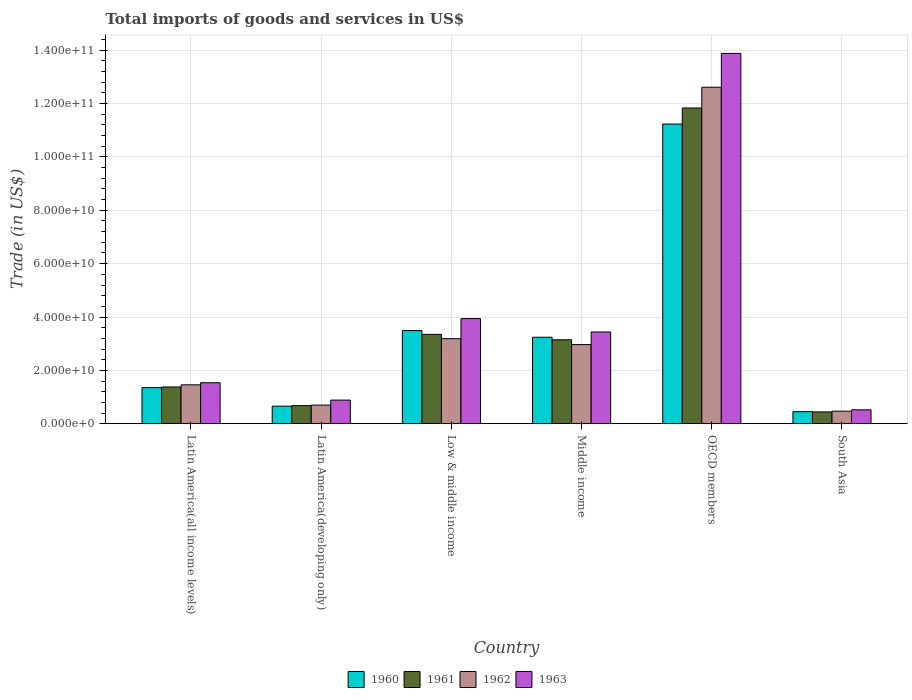Are the number of bars on each tick of the X-axis equal?
Your response must be concise. Yes. How many bars are there on the 6th tick from the left?
Ensure brevity in your answer.  4. How many bars are there on the 4th tick from the right?
Your answer should be very brief. 4. What is the label of the 4th group of bars from the left?
Offer a terse response. Middle income. What is the total imports of goods and services in 1960 in Middle income?
Your response must be concise. 3.24e+1. Across all countries, what is the maximum total imports of goods and services in 1960?
Offer a terse response. 1.12e+11. Across all countries, what is the minimum total imports of goods and services in 1961?
Offer a very short reply. 4.43e+09. In which country was the total imports of goods and services in 1961 maximum?
Your answer should be very brief. OECD members. What is the total total imports of goods and services in 1961 in the graph?
Make the answer very short. 2.08e+11. What is the difference between the total imports of goods and services in 1961 in Latin America(all income levels) and that in Latin America(developing only)?
Ensure brevity in your answer.  7.00e+09. What is the difference between the total imports of goods and services in 1961 in South Asia and the total imports of goods and services in 1962 in Middle income?
Make the answer very short. -2.52e+1. What is the average total imports of goods and services in 1963 per country?
Your answer should be compact. 4.03e+1. What is the difference between the total imports of goods and services of/in 1963 and total imports of goods and services of/in 1961 in Latin America(all income levels)?
Provide a succinct answer. 1.59e+09. In how many countries, is the total imports of goods and services in 1962 greater than 124000000000 US$?
Provide a short and direct response. 1. What is the ratio of the total imports of goods and services in 1963 in Latin America(all income levels) to that in OECD members?
Your answer should be compact. 0.11. Is the total imports of goods and services in 1963 in Latin America(all income levels) less than that in Middle income?
Provide a short and direct response. Yes. What is the difference between the highest and the second highest total imports of goods and services in 1963?
Offer a very short reply. 5.01e+09. What is the difference between the highest and the lowest total imports of goods and services in 1961?
Offer a terse response. 1.14e+11. In how many countries, is the total imports of goods and services in 1962 greater than the average total imports of goods and services in 1962 taken over all countries?
Ensure brevity in your answer.  1. What does the 4th bar from the left in Low & middle income represents?
Provide a short and direct response. 1963. Is it the case that in every country, the sum of the total imports of goods and services in 1961 and total imports of goods and services in 1960 is greater than the total imports of goods and services in 1962?
Provide a short and direct response. Yes. How many bars are there?
Make the answer very short. 24. How many countries are there in the graph?
Your answer should be compact. 6. What is the difference between two consecutive major ticks on the Y-axis?
Your response must be concise. 2.00e+1. Are the values on the major ticks of Y-axis written in scientific E-notation?
Give a very brief answer. Yes. Does the graph contain any zero values?
Your answer should be compact. No. Where does the legend appear in the graph?
Make the answer very short. Bottom center. How are the legend labels stacked?
Your answer should be very brief. Horizontal. What is the title of the graph?
Provide a short and direct response. Total imports of goods and services in US$. What is the label or title of the X-axis?
Provide a succinct answer. Country. What is the label or title of the Y-axis?
Provide a short and direct response. Trade (in US$). What is the Trade (in US$) of 1960 in Latin America(all income levels)?
Give a very brief answer. 1.35e+1. What is the Trade (in US$) of 1961 in Latin America(all income levels)?
Your answer should be very brief. 1.38e+1. What is the Trade (in US$) of 1962 in Latin America(all income levels)?
Provide a short and direct response. 1.46e+1. What is the Trade (in US$) of 1963 in Latin America(all income levels)?
Keep it short and to the point. 1.54e+1. What is the Trade (in US$) of 1960 in Latin America(developing only)?
Make the answer very short. 6.59e+09. What is the Trade (in US$) in 1961 in Latin America(developing only)?
Your response must be concise. 6.78e+09. What is the Trade (in US$) in 1962 in Latin America(developing only)?
Make the answer very short. 6.99e+09. What is the Trade (in US$) in 1963 in Latin America(developing only)?
Make the answer very short. 8.86e+09. What is the Trade (in US$) in 1960 in Low & middle income?
Ensure brevity in your answer.  3.49e+1. What is the Trade (in US$) of 1961 in Low & middle income?
Your response must be concise. 3.35e+1. What is the Trade (in US$) of 1962 in Low & middle income?
Offer a very short reply. 3.19e+1. What is the Trade (in US$) in 1963 in Low & middle income?
Your response must be concise. 3.94e+1. What is the Trade (in US$) in 1960 in Middle income?
Provide a succinct answer. 3.24e+1. What is the Trade (in US$) of 1961 in Middle income?
Make the answer very short. 3.15e+1. What is the Trade (in US$) of 1962 in Middle income?
Your response must be concise. 2.97e+1. What is the Trade (in US$) of 1963 in Middle income?
Give a very brief answer. 3.44e+1. What is the Trade (in US$) in 1960 in OECD members?
Ensure brevity in your answer.  1.12e+11. What is the Trade (in US$) of 1961 in OECD members?
Your answer should be very brief. 1.18e+11. What is the Trade (in US$) of 1962 in OECD members?
Your answer should be compact. 1.26e+11. What is the Trade (in US$) of 1963 in OECD members?
Your answer should be compact. 1.39e+11. What is the Trade (in US$) in 1960 in South Asia?
Offer a terse response. 4.53e+09. What is the Trade (in US$) of 1961 in South Asia?
Make the answer very short. 4.43e+09. What is the Trade (in US$) in 1962 in South Asia?
Make the answer very short. 4.71e+09. What is the Trade (in US$) of 1963 in South Asia?
Ensure brevity in your answer.  5.21e+09. Across all countries, what is the maximum Trade (in US$) of 1960?
Offer a very short reply. 1.12e+11. Across all countries, what is the maximum Trade (in US$) in 1961?
Offer a terse response. 1.18e+11. Across all countries, what is the maximum Trade (in US$) in 1962?
Your answer should be compact. 1.26e+11. Across all countries, what is the maximum Trade (in US$) in 1963?
Offer a terse response. 1.39e+11. Across all countries, what is the minimum Trade (in US$) in 1960?
Ensure brevity in your answer.  4.53e+09. Across all countries, what is the minimum Trade (in US$) in 1961?
Your response must be concise. 4.43e+09. Across all countries, what is the minimum Trade (in US$) of 1962?
Your response must be concise. 4.71e+09. Across all countries, what is the minimum Trade (in US$) in 1963?
Offer a terse response. 5.21e+09. What is the total Trade (in US$) in 1960 in the graph?
Provide a short and direct response. 2.04e+11. What is the total Trade (in US$) in 1961 in the graph?
Provide a succinct answer. 2.08e+11. What is the total Trade (in US$) of 1962 in the graph?
Your answer should be compact. 2.14e+11. What is the total Trade (in US$) of 1963 in the graph?
Provide a short and direct response. 2.42e+11. What is the difference between the Trade (in US$) of 1960 in Latin America(all income levels) and that in Latin America(developing only)?
Provide a succinct answer. 6.94e+09. What is the difference between the Trade (in US$) in 1961 in Latin America(all income levels) and that in Latin America(developing only)?
Keep it short and to the point. 7.00e+09. What is the difference between the Trade (in US$) in 1962 in Latin America(all income levels) and that in Latin America(developing only)?
Your response must be concise. 7.59e+09. What is the difference between the Trade (in US$) of 1963 in Latin America(all income levels) and that in Latin America(developing only)?
Provide a succinct answer. 6.50e+09. What is the difference between the Trade (in US$) of 1960 in Latin America(all income levels) and that in Low & middle income?
Offer a very short reply. -2.14e+1. What is the difference between the Trade (in US$) in 1961 in Latin America(all income levels) and that in Low & middle income?
Offer a terse response. -1.97e+1. What is the difference between the Trade (in US$) of 1962 in Latin America(all income levels) and that in Low & middle income?
Offer a very short reply. -1.73e+1. What is the difference between the Trade (in US$) in 1963 in Latin America(all income levels) and that in Low & middle income?
Ensure brevity in your answer.  -2.40e+1. What is the difference between the Trade (in US$) in 1960 in Latin America(all income levels) and that in Middle income?
Offer a very short reply. -1.89e+1. What is the difference between the Trade (in US$) in 1961 in Latin America(all income levels) and that in Middle income?
Make the answer very short. -1.77e+1. What is the difference between the Trade (in US$) of 1962 in Latin America(all income levels) and that in Middle income?
Keep it short and to the point. -1.51e+1. What is the difference between the Trade (in US$) in 1963 in Latin America(all income levels) and that in Middle income?
Provide a short and direct response. -1.90e+1. What is the difference between the Trade (in US$) in 1960 in Latin America(all income levels) and that in OECD members?
Your answer should be compact. -9.88e+1. What is the difference between the Trade (in US$) in 1961 in Latin America(all income levels) and that in OECD members?
Provide a succinct answer. -1.05e+11. What is the difference between the Trade (in US$) of 1962 in Latin America(all income levels) and that in OECD members?
Offer a very short reply. -1.12e+11. What is the difference between the Trade (in US$) in 1963 in Latin America(all income levels) and that in OECD members?
Your response must be concise. -1.23e+11. What is the difference between the Trade (in US$) in 1960 in Latin America(all income levels) and that in South Asia?
Make the answer very short. 9.00e+09. What is the difference between the Trade (in US$) in 1961 in Latin America(all income levels) and that in South Asia?
Ensure brevity in your answer.  9.35e+09. What is the difference between the Trade (in US$) of 1962 in Latin America(all income levels) and that in South Asia?
Offer a very short reply. 9.87e+09. What is the difference between the Trade (in US$) in 1963 in Latin America(all income levels) and that in South Asia?
Keep it short and to the point. 1.02e+1. What is the difference between the Trade (in US$) in 1960 in Latin America(developing only) and that in Low & middle income?
Give a very brief answer. -2.83e+1. What is the difference between the Trade (in US$) of 1961 in Latin America(developing only) and that in Low & middle income?
Give a very brief answer. -2.67e+1. What is the difference between the Trade (in US$) of 1962 in Latin America(developing only) and that in Low & middle income?
Your answer should be very brief. -2.49e+1. What is the difference between the Trade (in US$) in 1963 in Latin America(developing only) and that in Low & middle income?
Your answer should be compact. -3.05e+1. What is the difference between the Trade (in US$) of 1960 in Latin America(developing only) and that in Middle income?
Provide a short and direct response. -2.58e+1. What is the difference between the Trade (in US$) of 1961 in Latin America(developing only) and that in Middle income?
Offer a terse response. -2.47e+1. What is the difference between the Trade (in US$) in 1962 in Latin America(developing only) and that in Middle income?
Your answer should be compact. -2.27e+1. What is the difference between the Trade (in US$) of 1963 in Latin America(developing only) and that in Middle income?
Provide a short and direct response. -2.55e+1. What is the difference between the Trade (in US$) in 1960 in Latin America(developing only) and that in OECD members?
Your response must be concise. -1.06e+11. What is the difference between the Trade (in US$) of 1961 in Latin America(developing only) and that in OECD members?
Give a very brief answer. -1.12e+11. What is the difference between the Trade (in US$) in 1962 in Latin America(developing only) and that in OECD members?
Your response must be concise. -1.19e+11. What is the difference between the Trade (in US$) of 1963 in Latin America(developing only) and that in OECD members?
Offer a very short reply. -1.30e+11. What is the difference between the Trade (in US$) of 1960 in Latin America(developing only) and that in South Asia?
Offer a very short reply. 2.06e+09. What is the difference between the Trade (in US$) of 1961 in Latin America(developing only) and that in South Asia?
Offer a terse response. 2.35e+09. What is the difference between the Trade (in US$) in 1962 in Latin America(developing only) and that in South Asia?
Give a very brief answer. 2.27e+09. What is the difference between the Trade (in US$) in 1963 in Latin America(developing only) and that in South Asia?
Ensure brevity in your answer.  3.65e+09. What is the difference between the Trade (in US$) in 1960 in Low & middle income and that in Middle income?
Keep it short and to the point. 2.50e+09. What is the difference between the Trade (in US$) in 1961 in Low & middle income and that in Middle income?
Make the answer very short. 2.04e+09. What is the difference between the Trade (in US$) in 1962 in Low & middle income and that in Middle income?
Make the answer very short. 2.21e+09. What is the difference between the Trade (in US$) in 1963 in Low & middle income and that in Middle income?
Make the answer very short. 5.01e+09. What is the difference between the Trade (in US$) in 1960 in Low & middle income and that in OECD members?
Provide a short and direct response. -7.74e+1. What is the difference between the Trade (in US$) of 1961 in Low & middle income and that in OECD members?
Provide a succinct answer. -8.48e+1. What is the difference between the Trade (in US$) of 1962 in Low & middle income and that in OECD members?
Make the answer very short. -9.43e+1. What is the difference between the Trade (in US$) of 1963 in Low & middle income and that in OECD members?
Offer a terse response. -9.94e+1. What is the difference between the Trade (in US$) of 1960 in Low & middle income and that in South Asia?
Provide a short and direct response. 3.04e+1. What is the difference between the Trade (in US$) of 1961 in Low & middle income and that in South Asia?
Provide a short and direct response. 2.91e+1. What is the difference between the Trade (in US$) in 1962 in Low & middle income and that in South Asia?
Give a very brief answer. 2.72e+1. What is the difference between the Trade (in US$) of 1963 in Low & middle income and that in South Asia?
Your response must be concise. 3.42e+1. What is the difference between the Trade (in US$) in 1960 in Middle income and that in OECD members?
Make the answer very short. -7.99e+1. What is the difference between the Trade (in US$) of 1961 in Middle income and that in OECD members?
Provide a short and direct response. -8.69e+1. What is the difference between the Trade (in US$) of 1962 in Middle income and that in OECD members?
Your answer should be compact. -9.65e+1. What is the difference between the Trade (in US$) in 1963 in Middle income and that in OECD members?
Make the answer very short. -1.04e+11. What is the difference between the Trade (in US$) in 1960 in Middle income and that in South Asia?
Your answer should be compact. 2.79e+1. What is the difference between the Trade (in US$) in 1961 in Middle income and that in South Asia?
Make the answer very short. 2.70e+1. What is the difference between the Trade (in US$) of 1962 in Middle income and that in South Asia?
Your response must be concise. 2.50e+1. What is the difference between the Trade (in US$) in 1963 in Middle income and that in South Asia?
Your answer should be compact. 2.92e+1. What is the difference between the Trade (in US$) in 1960 in OECD members and that in South Asia?
Ensure brevity in your answer.  1.08e+11. What is the difference between the Trade (in US$) of 1961 in OECD members and that in South Asia?
Give a very brief answer. 1.14e+11. What is the difference between the Trade (in US$) in 1962 in OECD members and that in South Asia?
Your answer should be compact. 1.21e+11. What is the difference between the Trade (in US$) in 1963 in OECD members and that in South Asia?
Offer a terse response. 1.34e+11. What is the difference between the Trade (in US$) in 1960 in Latin America(all income levels) and the Trade (in US$) in 1961 in Latin America(developing only)?
Offer a very short reply. 6.75e+09. What is the difference between the Trade (in US$) of 1960 in Latin America(all income levels) and the Trade (in US$) of 1962 in Latin America(developing only)?
Ensure brevity in your answer.  6.55e+09. What is the difference between the Trade (in US$) of 1960 in Latin America(all income levels) and the Trade (in US$) of 1963 in Latin America(developing only)?
Provide a succinct answer. 4.67e+09. What is the difference between the Trade (in US$) of 1961 in Latin America(all income levels) and the Trade (in US$) of 1962 in Latin America(developing only)?
Provide a succinct answer. 6.79e+09. What is the difference between the Trade (in US$) of 1961 in Latin America(all income levels) and the Trade (in US$) of 1963 in Latin America(developing only)?
Offer a terse response. 4.92e+09. What is the difference between the Trade (in US$) of 1962 in Latin America(all income levels) and the Trade (in US$) of 1963 in Latin America(developing only)?
Ensure brevity in your answer.  5.72e+09. What is the difference between the Trade (in US$) in 1960 in Latin America(all income levels) and the Trade (in US$) in 1961 in Low & middle income?
Ensure brevity in your answer.  -2.00e+1. What is the difference between the Trade (in US$) of 1960 in Latin America(all income levels) and the Trade (in US$) of 1962 in Low & middle income?
Make the answer very short. -1.83e+1. What is the difference between the Trade (in US$) in 1960 in Latin America(all income levels) and the Trade (in US$) in 1963 in Low & middle income?
Give a very brief answer. -2.59e+1. What is the difference between the Trade (in US$) of 1961 in Latin America(all income levels) and the Trade (in US$) of 1962 in Low & middle income?
Make the answer very short. -1.81e+1. What is the difference between the Trade (in US$) of 1961 in Latin America(all income levels) and the Trade (in US$) of 1963 in Low & middle income?
Give a very brief answer. -2.56e+1. What is the difference between the Trade (in US$) of 1962 in Latin America(all income levels) and the Trade (in US$) of 1963 in Low & middle income?
Provide a short and direct response. -2.48e+1. What is the difference between the Trade (in US$) of 1960 in Latin America(all income levels) and the Trade (in US$) of 1961 in Middle income?
Your response must be concise. -1.79e+1. What is the difference between the Trade (in US$) in 1960 in Latin America(all income levels) and the Trade (in US$) in 1962 in Middle income?
Keep it short and to the point. -1.61e+1. What is the difference between the Trade (in US$) of 1960 in Latin America(all income levels) and the Trade (in US$) of 1963 in Middle income?
Your answer should be compact. -2.09e+1. What is the difference between the Trade (in US$) of 1961 in Latin America(all income levels) and the Trade (in US$) of 1962 in Middle income?
Offer a very short reply. -1.59e+1. What is the difference between the Trade (in US$) of 1961 in Latin America(all income levels) and the Trade (in US$) of 1963 in Middle income?
Offer a terse response. -2.06e+1. What is the difference between the Trade (in US$) of 1962 in Latin America(all income levels) and the Trade (in US$) of 1963 in Middle income?
Make the answer very short. -1.98e+1. What is the difference between the Trade (in US$) in 1960 in Latin America(all income levels) and the Trade (in US$) in 1961 in OECD members?
Provide a succinct answer. -1.05e+11. What is the difference between the Trade (in US$) in 1960 in Latin America(all income levels) and the Trade (in US$) in 1962 in OECD members?
Give a very brief answer. -1.13e+11. What is the difference between the Trade (in US$) of 1960 in Latin America(all income levels) and the Trade (in US$) of 1963 in OECD members?
Keep it short and to the point. -1.25e+11. What is the difference between the Trade (in US$) in 1961 in Latin America(all income levels) and the Trade (in US$) in 1962 in OECD members?
Your response must be concise. -1.12e+11. What is the difference between the Trade (in US$) in 1961 in Latin America(all income levels) and the Trade (in US$) in 1963 in OECD members?
Give a very brief answer. -1.25e+11. What is the difference between the Trade (in US$) of 1962 in Latin America(all income levels) and the Trade (in US$) of 1963 in OECD members?
Ensure brevity in your answer.  -1.24e+11. What is the difference between the Trade (in US$) in 1960 in Latin America(all income levels) and the Trade (in US$) in 1961 in South Asia?
Make the answer very short. 9.10e+09. What is the difference between the Trade (in US$) of 1960 in Latin America(all income levels) and the Trade (in US$) of 1962 in South Asia?
Give a very brief answer. 8.82e+09. What is the difference between the Trade (in US$) in 1960 in Latin America(all income levels) and the Trade (in US$) in 1963 in South Asia?
Your response must be concise. 8.32e+09. What is the difference between the Trade (in US$) in 1961 in Latin America(all income levels) and the Trade (in US$) in 1962 in South Asia?
Keep it short and to the point. 9.07e+09. What is the difference between the Trade (in US$) of 1961 in Latin America(all income levels) and the Trade (in US$) of 1963 in South Asia?
Ensure brevity in your answer.  8.57e+09. What is the difference between the Trade (in US$) of 1962 in Latin America(all income levels) and the Trade (in US$) of 1963 in South Asia?
Offer a terse response. 9.37e+09. What is the difference between the Trade (in US$) in 1960 in Latin America(developing only) and the Trade (in US$) in 1961 in Low & middle income?
Your answer should be very brief. -2.69e+1. What is the difference between the Trade (in US$) in 1960 in Latin America(developing only) and the Trade (in US$) in 1962 in Low & middle income?
Your answer should be very brief. -2.53e+1. What is the difference between the Trade (in US$) in 1960 in Latin America(developing only) and the Trade (in US$) in 1963 in Low & middle income?
Provide a short and direct response. -3.28e+1. What is the difference between the Trade (in US$) in 1961 in Latin America(developing only) and the Trade (in US$) in 1962 in Low & middle income?
Your response must be concise. -2.51e+1. What is the difference between the Trade (in US$) of 1961 in Latin America(developing only) and the Trade (in US$) of 1963 in Low & middle income?
Offer a very short reply. -3.26e+1. What is the difference between the Trade (in US$) of 1962 in Latin America(developing only) and the Trade (in US$) of 1963 in Low & middle income?
Your answer should be very brief. -3.24e+1. What is the difference between the Trade (in US$) of 1960 in Latin America(developing only) and the Trade (in US$) of 1961 in Middle income?
Provide a short and direct response. -2.49e+1. What is the difference between the Trade (in US$) in 1960 in Latin America(developing only) and the Trade (in US$) in 1962 in Middle income?
Give a very brief answer. -2.31e+1. What is the difference between the Trade (in US$) of 1960 in Latin America(developing only) and the Trade (in US$) of 1963 in Middle income?
Your response must be concise. -2.78e+1. What is the difference between the Trade (in US$) of 1961 in Latin America(developing only) and the Trade (in US$) of 1962 in Middle income?
Your response must be concise. -2.29e+1. What is the difference between the Trade (in US$) of 1961 in Latin America(developing only) and the Trade (in US$) of 1963 in Middle income?
Your response must be concise. -2.76e+1. What is the difference between the Trade (in US$) of 1962 in Latin America(developing only) and the Trade (in US$) of 1963 in Middle income?
Provide a short and direct response. -2.74e+1. What is the difference between the Trade (in US$) of 1960 in Latin America(developing only) and the Trade (in US$) of 1961 in OECD members?
Offer a terse response. -1.12e+11. What is the difference between the Trade (in US$) of 1960 in Latin America(developing only) and the Trade (in US$) of 1962 in OECD members?
Offer a very short reply. -1.20e+11. What is the difference between the Trade (in US$) of 1960 in Latin America(developing only) and the Trade (in US$) of 1963 in OECD members?
Provide a succinct answer. -1.32e+11. What is the difference between the Trade (in US$) in 1961 in Latin America(developing only) and the Trade (in US$) in 1962 in OECD members?
Your response must be concise. -1.19e+11. What is the difference between the Trade (in US$) of 1961 in Latin America(developing only) and the Trade (in US$) of 1963 in OECD members?
Provide a short and direct response. -1.32e+11. What is the difference between the Trade (in US$) of 1962 in Latin America(developing only) and the Trade (in US$) of 1963 in OECD members?
Your answer should be very brief. -1.32e+11. What is the difference between the Trade (in US$) of 1960 in Latin America(developing only) and the Trade (in US$) of 1961 in South Asia?
Your response must be concise. 2.16e+09. What is the difference between the Trade (in US$) of 1960 in Latin America(developing only) and the Trade (in US$) of 1962 in South Asia?
Offer a terse response. 1.88e+09. What is the difference between the Trade (in US$) in 1960 in Latin America(developing only) and the Trade (in US$) in 1963 in South Asia?
Offer a very short reply. 1.38e+09. What is the difference between the Trade (in US$) in 1961 in Latin America(developing only) and the Trade (in US$) in 1962 in South Asia?
Provide a succinct answer. 2.07e+09. What is the difference between the Trade (in US$) in 1961 in Latin America(developing only) and the Trade (in US$) in 1963 in South Asia?
Your answer should be compact. 1.57e+09. What is the difference between the Trade (in US$) in 1962 in Latin America(developing only) and the Trade (in US$) in 1963 in South Asia?
Provide a short and direct response. 1.77e+09. What is the difference between the Trade (in US$) of 1960 in Low & middle income and the Trade (in US$) of 1961 in Middle income?
Give a very brief answer. 3.46e+09. What is the difference between the Trade (in US$) of 1960 in Low & middle income and the Trade (in US$) of 1962 in Middle income?
Your response must be concise. 5.26e+09. What is the difference between the Trade (in US$) of 1960 in Low & middle income and the Trade (in US$) of 1963 in Middle income?
Give a very brief answer. 5.30e+08. What is the difference between the Trade (in US$) in 1961 in Low & middle income and the Trade (in US$) in 1962 in Middle income?
Offer a very short reply. 3.84e+09. What is the difference between the Trade (in US$) of 1961 in Low & middle income and the Trade (in US$) of 1963 in Middle income?
Offer a terse response. -8.90e+08. What is the difference between the Trade (in US$) in 1962 in Low & middle income and the Trade (in US$) in 1963 in Middle income?
Your answer should be very brief. -2.51e+09. What is the difference between the Trade (in US$) in 1960 in Low & middle income and the Trade (in US$) in 1961 in OECD members?
Provide a succinct answer. -8.34e+1. What is the difference between the Trade (in US$) of 1960 in Low & middle income and the Trade (in US$) of 1962 in OECD members?
Your answer should be compact. -9.12e+1. What is the difference between the Trade (in US$) of 1960 in Low & middle income and the Trade (in US$) of 1963 in OECD members?
Your answer should be very brief. -1.04e+11. What is the difference between the Trade (in US$) in 1961 in Low & middle income and the Trade (in US$) in 1962 in OECD members?
Offer a terse response. -9.26e+1. What is the difference between the Trade (in US$) in 1961 in Low & middle income and the Trade (in US$) in 1963 in OECD members?
Your response must be concise. -1.05e+11. What is the difference between the Trade (in US$) in 1962 in Low & middle income and the Trade (in US$) in 1963 in OECD members?
Your answer should be compact. -1.07e+11. What is the difference between the Trade (in US$) in 1960 in Low & middle income and the Trade (in US$) in 1961 in South Asia?
Provide a succinct answer. 3.05e+1. What is the difference between the Trade (in US$) of 1960 in Low & middle income and the Trade (in US$) of 1962 in South Asia?
Give a very brief answer. 3.02e+1. What is the difference between the Trade (in US$) in 1960 in Low & middle income and the Trade (in US$) in 1963 in South Asia?
Make the answer very short. 2.97e+1. What is the difference between the Trade (in US$) in 1961 in Low & middle income and the Trade (in US$) in 1962 in South Asia?
Provide a succinct answer. 2.88e+1. What is the difference between the Trade (in US$) in 1961 in Low & middle income and the Trade (in US$) in 1963 in South Asia?
Give a very brief answer. 2.83e+1. What is the difference between the Trade (in US$) in 1962 in Low & middle income and the Trade (in US$) in 1963 in South Asia?
Your response must be concise. 2.67e+1. What is the difference between the Trade (in US$) in 1960 in Middle income and the Trade (in US$) in 1961 in OECD members?
Ensure brevity in your answer.  -8.59e+1. What is the difference between the Trade (in US$) in 1960 in Middle income and the Trade (in US$) in 1962 in OECD members?
Give a very brief answer. -9.37e+1. What is the difference between the Trade (in US$) of 1960 in Middle income and the Trade (in US$) of 1963 in OECD members?
Your answer should be very brief. -1.06e+11. What is the difference between the Trade (in US$) in 1961 in Middle income and the Trade (in US$) in 1962 in OECD members?
Offer a terse response. -9.47e+1. What is the difference between the Trade (in US$) in 1961 in Middle income and the Trade (in US$) in 1963 in OECD members?
Keep it short and to the point. -1.07e+11. What is the difference between the Trade (in US$) in 1962 in Middle income and the Trade (in US$) in 1963 in OECD members?
Keep it short and to the point. -1.09e+11. What is the difference between the Trade (in US$) in 1960 in Middle income and the Trade (in US$) in 1961 in South Asia?
Keep it short and to the point. 2.80e+1. What is the difference between the Trade (in US$) in 1960 in Middle income and the Trade (in US$) in 1962 in South Asia?
Ensure brevity in your answer.  2.77e+1. What is the difference between the Trade (in US$) of 1960 in Middle income and the Trade (in US$) of 1963 in South Asia?
Your response must be concise. 2.72e+1. What is the difference between the Trade (in US$) of 1961 in Middle income and the Trade (in US$) of 1962 in South Asia?
Offer a terse response. 2.68e+1. What is the difference between the Trade (in US$) in 1961 in Middle income and the Trade (in US$) in 1963 in South Asia?
Ensure brevity in your answer.  2.63e+1. What is the difference between the Trade (in US$) of 1962 in Middle income and the Trade (in US$) of 1963 in South Asia?
Your answer should be very brief. 2.45e+1. What is the difference between the Trade (in US$) in 1960 in OECD members and the Trade (in US$) in 1961 in South Asia?
Give a very brief answer. 1.08e+11. What is the difference between the Trade (in US$) in 1960 in OECD members and the Trade (in US$) in 1962 in South Asia?
Keep it short and to the point. 1.08e+11. What is the difference between the Trade (in US$) of 1960 in OECD members and the Trade (in US$) of 1963 in South Asia?
Your response must be concise. 1.07e+11. What is the difference between the Trade (in US$) in 1961 in OECD members and the Trade (in US$) in 1962 in South Asia?
Offer a terse response. 1.14e+11. What is the difference between the Trade (in US$) of 1961 in OECD members and the Trade (in US$) of 1963 in South Asia?
Offer a terse response. 1.13e+11. What is the difference between the Trade (in US$) of 1962 in OECD members and the Trade (in US$) of 1963 in South Asia?
Provide a succinct answer. 1.21e+11. What is the average Trade (in US$) of 1960 per country?
Keep it short and to the point. 3.41e+1. What is the average Trade (in US$) of 1961 per country?
Offer a very short reply. 3.47e+1. What is the average Trade (in US$) of 1962 per country?
Give a very brief answer. 3.57e+1. What is the average Trade (in US$) in 1963 per country?
Offer a very short reply. 4.03e+1. What is the difference between the Trade (in US$) of 1960 and Trade (in US$) of 1961 in Latin America(all income levels)?
Offer a very short reply. -2.48e+08. What is the difference between the Trade (in US$) in 1960 and Trade (in US$) in 1962 in Latin America(all income levels)?
Ensure brevity in your answer.  -1.05e+09. What is the difference between the Trade (in US$) in 1960 and Trade (in US$) in 1963 in Latin America(all income levels)?
Offer a very short reply. -1.83e+09. What is the difference between the Trade (in US$) in 1961 and Trade (in US$) in 1962 in Latin America(all income levels)?
Your response must be concise. -7.99e+08. What is the difference between the Trade (in US$) of 1961 and Trade (in US$) of 1963 in Latin America(all income levels)?
Keep it short and to the point. -1.59e+09. What is the difference between the Trade (in US$) in 1962 and Trade (in US$) in 1963 in Latin America(all income levels)?
Offer a terse response. -7.87e+08. What is the difference between the Trade (in US$) in 1960 and Trade (in US$) in 1961 in Latin America(developing only)?
Offer a very short reply. -1.91e+08. What is the difference between the Trade (in US$) in 1960 and Trade (in US$) in 1962 in Latin America(developing only)?
Provide a short and direct response. -3.96e+08. What is the difference between the Trade (in US$) in 1960 and Trade (in US$) in 1963 in Latin America(developing only)?
Ensure brevity in your answer.  -2.27e+09. What is the difference between the Trade (in US$) in 1961 and Trade (in US$) in 1962 in Latin America(developing only)?
Your response must be concise. -2.05e+08. What is the difference between the Trade (in US$) in 1961 and Trade (in US$) in 1963 in Latin America(developing only)?
Make the answer very short. -2.08e+09. What is the difference between the Trade (in US$) of 1962 and Trade (in US$) of 1963 in Latin America(developing only)?
Provide a short and direct response. -1.88e+09. What is the difference between the Trade (in US$) in 1960 and Trade (in US$) in 1961 in Low & middle income?
Offer a very short reply. 1.42e+09. What is the difference between the Trade (in US$) in 1960 and Trade (in US$) in 1962 in Low & middle income?
Give a very brief answer. 3.05e+09. What is the difference between the Trade (in US$) of 1960 and Trade (in US$) of 1963 in Low & middle income?
Provide a succinct answer. -4.48e+09. What is the difference between the Trade (in US$) in 1961 and Trade (in US$) in 1962 in Low & middle income?
Give a very brief answer. 1.62e+09. What is the difference between the Trade (in US$) in 1961 and Trade (in US$) in 1963 in Low & middle income?
Your response must be concise. -5.90e+09. What is the difference between the Trade (in US$) in 1962 and Trade (in US$) in 1963 in Low & middle income?
Your response must be concise. -7.52e+09. What is the difference between the Trade (in US$) in 1960 and Trade (in US$) in 1961 in Middle income?
Your response must be concise. 9.57e+08. What is the difference between the Trade (in US$) in 1960 and Trade (in US$) in 1962 in Middle income?
Make the answer very short. 2.76e+09. What is the difference between the Trade (in US$) of 1960 and Trade (in US$) of 1963 in Middle income?
Keep it short and to the point. -1.97e+09. What is the difference between the Trade (in US$) in 1961 and Trade (in US$) in 1962 in Middle income?
Keep it short and to the point. 1.80e+09. What is the difference between the Trade (in US$) of 1961 and Trade (in US$) of 1963 in Middle income?
Your answer should be very brief. -2.93e+09. What is the difference between the Trade (in US$) of 1962 and Trade (in US$) of 1963 in Middle income?
Offer a terse response. -4.73e+09. What is the difference between the Trade (in US$) of 1960 and Trade (in US$) of 1961 in OECD members?
Keep it short and to the point. -6.01e+09. What is the difference between the Trade (in US$) in 1960 and Trade (in US$) in 1962 in OECD members?
Your response must be concise. -1.38e+1. What is the difference between the Trade (in US$) of 1960 and Trade (in US$) of 1963 in OECD members?
Keep it short and to the point. -2.65e+1. What is the difference between the Trade (in US$) in 1961 and Trade (in US$) in 1962 in OECD members?
Keep it short and to the point. -7.79e+09. What is the difference between the Trade (in US$) in 1961 and Trade (in US$) in 1963 in OECD members?
Ensure brevity in your answer.  -2.05e+1. What is the difference between the Trade (in US$) of 1962 and Trade (in US$) of 1963 in OECD members?
Offer a very short reply. -1.27e+1. What is the difference between the Trade (in US$) in 1960 and Trade (in US$) in 1961 in South Asia?
Your answer should be compact. 9.31e+07. What is the difference between the Trade (in US$) of 1960 and Trade (in US$) of 1962 in South Asia?
Keep it short and to the point. -1.84e+08. What is the difference between the Trade (in US$) in 1960 and Trade (in US$) in 1963 in South Asia?
Ensure brevity in your answer.  -6.84e+08. What is the difference between the Trade (in US$) of 1961 and Trade (in US$) of 1962 in South Asia?
Provide a succinct answer. -2.77e+08. What is the difference between the Trade (in US$) in 1961 and Trade (in US$) in 1963 in South Asia?
Your response must be concise. -7.77e+08. What is the difference between the Trade (in US$) in 1962 and Trade (in US$) in 1963 in South Asia?
Give a very brief answer. -5.00e+08. What is the ratio of the Trade (in US$) of 1960 in Latin America(all income levels) to that in Latin America(developing only)?
Make the answer very short. 2.05. What is the ratio of the Trade (in US$) of 1961 in Latin America(all income levels) to that in Latin America(developing only)?
Offer a very short reply. 2.03. What is the ratio of the Trade (in US$) in 1962 in Latin America(all income levels) to that in Latin America(developing only)?
Offer a terse response. 2.09. What is the ratio of the Trade (in US$) of 1963 in Latin America(all income levels) to that in Latin America(developing only)?
Your answer should be very brief. 1.73. What is the ratio of the Trade (in US$) of 1960 in Latin America(all income levels) to that in Low & middle income?
Provide a short and direct response. 0.39. What is the ratio of the Trade (in US$) of 1961 in Latin America(all income levels) to that in Low & middle income?
Your answer should be compact. 0.41. What is the ratio of the Trade (in US$) in 1962 in Latin America(all income levels) to that in Low & middle income?
Keep it short and to the point. 0.46. What is the ratio of the Trade (in US$) in 1963 in Latin America(all income levels) to that in Low & middle income?
Offer a very short reply. 0.39. What is the ratio of the Trade (in US$) in 1960 in Latin America(all income levels) to that in Middle income?
Your response must be concise. 0.42. What is the ratio of the Trade (in US$) in 1961 in Latin America(all income levels) to that in Middle income?
Provide a succinct answer. 0.44. What is the ratio of the Trade (in US$) in 1962 in Latin America(all income levels) to that in Middle income?
Ensure brevity in your answer.  0.49. What is the ratio of the Trade (in US$) of 1963 in Latin America(all income levels) to that in Middle income?
Your answer should be very brief. 0.45. What is the ratio of the Trade (in US$) of 1960 in Latin America(all income levels) to that in OECD members?
Your answer should be very brief. 0.12. What is the ratio of the Trade (in US$) of 1961 in Latin America(all income levels) to that in OECD members?
Your answer should be very brief. 0.12. What is the ratio of the Trade (in US$) of 1962 in Latin America(all income levels) to that in OECD members?
Your response must be concise. 0.12. What is the ratio of the Trade (in US$) of 1963 in Latin America(all income levels) to that in OECD members?
Offer a very short reply. 0.11. What is the ratio of the Trade (in US$) of 1960 in Latin America(all income levels) to that in South Asia?
Provide a short and direct response. 2.99. What is the ratio of the Trade (in US$) in 1961 in Latin America(all income levels) to that in South Asia?
Your response must be concise. 3.11. What is the ratio of the Trade (in US$) in 1962 in Latin America(all income levels) to that in South Asia?
Make the answer very short. 3.09. What is the ratio of the Trade (in US$) of 1963 in Latin America(all income levels) to that in South Asia?
Your response must be concise. 2.95. What is the ratio of the Trade (in US$) in 1960 in Latin America(developing only) to that in Low & middle income?
Provide a short and direct response. 0.19. What is the ratio of the Trade (in US$) of 1961 in Latin America(developing only) to that in Low & middle income?
Offer a very short reply. 0.2. What is the ratio of the Trade (in US$) in 1962 in Latin America(developing only) to that in Low & middle income?
Offer a very short reply. 0.22. What is the ratio of the Trade (in US$) of 1963 in Latin America(developing only) to that in Low & middle income?
Offer a very short reply. 0.22. What is the ratio of the Trade (in US$) in 1960 in Latin America(developing only) to that in Middle income?
Ensure brevity in your answer.  0.2. What is the ratio of the Trade (in US$) of 1961 in Latin America(developing only) to that in Middle income?
Make the answer very short. 0.22. What is the ratio of the Trade (in US$) of 1962 in Latin America(developing only) to that in Middle income?
Keep it short and to the point. 0.24. What is the ratio of the Trade (in US$) of 1963 in Latin America(developing only) to that in Middle income?
Your answer should be very brief. 0.26. What is the ratio of the Trade (in US$) in 1960 in Latin America(developing only) to that in OECD members?
Give a very brief answer. 0.06. What is the ratio of the Trade (in US$) in 1961 in Latin America(developing only) to that in OECD members?
Offer a terse response. 0.06. What is the ratio of the Trade (in US$) in 1962 in Latin America(developing only) to that in OECD members?
Provide a short and direct response. 0.06. What is the ratio of the Trade (in US$) of 1963 in Latin America(developing only) to that in OECD members?
Your response must be concise. 0.06. What is the ratio of the Trade (in US$) in 1960 in Latin America(developing only) to that in South Asia?
Give a very brief answer. 1.46. What is the ratio of the Trade (in US$) of 1961 in Latin America(developing only) to that in South Asia?
Ensure brevity in your answer.  1.53. What is the ratio of the Trade (in US$) in 1962 in Latin America(developing only) to that in South Asia?
Make the answer very short. 1.48. What is the ratio of the Trade (in US$) in 1963 in Latin America(developing only) to that in South Asia?
Provide a short and direct response. 1.7. What is the ratio of the Trade (in US$) in 1960 in Low & middle income to that in Middle income?
Ensure brevity in your answer.  1.08. What is the ratio of the Trade (in US$) of 1961 in Low & middle income to that in Middle income?
Ensure brevity in your answer.  1.06. What is the ratio of the Trade (in US$) of 1962 in Low & middle income to that in Middle income?
Offer a terse response. 1.07. What is the ratio of the Trade (in US$) of 1963 in Low & middle income to that in Middle income?
Your response must be concise. 1.15. What is the ratio of the Trade (in US$) in 1960 in Low & middle income to that in OECD members?
Ensure brevity in your answer.  0.31. What is the ratio of the Trade (in US$) in 1961 in Low & middle income to that in OECD members?
Provide a succinct answer. 0.28. What is the ratio of the Trade (in US$) in 1962 in Low & middle income to that in OECD members?
Make the answer very short. 0.25. What is the ratio of the Trade (in US$) in 1963 in Low & middle income to that in OECD members?
Make the answer very short. 0.28. What is the ratio of the Trade (in US$) in 1960 in Low & middle income to that in South Asia?
Keep it short and to the point. 7.71. What is the ratio of the Trade (in US$) of 1961 in Low & middle income to that in South Asia?
Provide a succinct answer. 7.55. What is the ratio of the Trade (in US$) in 1962 in Low & middle income to that in South Asia?
Offer a very short reply. 6.77. What is the ratio of the Trade (in US$) in 1963 in Low & middle income to that in South Asia?
Make the answer very short. 7.56. What is the ratio of the Trade (in US$) in 1960 in Middle income to that in OECD members?
Offer a very short reply. 0.29. What is the ratio of the Trade (in US$) of 1961 in Middle income to that in OECD members?
Make the answer very short. 0.27. What is the ratio of the Trade (in US$) in 1962 in Middle income to that in OECD members?
Your response must be concise. 0.24. What is the ratio of the Trade (in US$) in 1963 in Middle income to that in OECD members?
Provide a short and direct response. 0.25. What is the ratio of the Trade (in US$) of 1960 in Middle income to that in South Asia?
Ensure brevity in your answer.  7.16. What is the ratio of the Trade (in US$) in 1961 in Middle income to that in South Asia?
Provide a succinct answer. 7.1. What is the ratio of the Trade (in US$) of 1962 in Middle income to that in South Asia?
Ensure brevity in your answer.  6.3. What is the ratio of the Trade (in US$) in 1963 in Middle income to that in South Asia?
Give a very brief answer. 6.6. What is the ratio of the Trade (in US$) in 1960 in OECD members to that in South Asia?
Make the answer very short. 24.81. What is the ratio of the Trade (in US$) in 1961 in OECD members to that in South Asia?
Your answer should be compact. 26.69. What is the ratio of the Trade (in US$) in 1962 in OECD members to that in South Asia?
Give a very brief answer. 26.77. What is the ratio of the Trade (in US$) of 1963 in OECD members to that in South Asia?
Your answer should be compact. 26.63. What is the difference between the highest and the second highest Trade (in US$) of 1960?
Your answer should be very brief. 7.74e+1. What is the difference between the highest and the second highest Trade (in US$) of 1961?
Provide a short and direct response. 8.48e+1. What is the difference between the highest and the second highest Trade (in US$) in 1962?
Your answer should be compact. 9.43e+1. What is the difference between the highest and the second highest Trade (in US$) of 1963?
Ensure brevity in your answer.  9.94e+1. What is the difference between the highest and the lowest Trade (in US$) of 1960?
Provide a short and direct response. 1.08e+11. What is the difference between the highest and the lowest Trade (in US$) in 1961?
Your answer should be very brief. 1.14e+11. What is the difference between the highest and the lowest Trade (in US$) of 1962?
Provide a short and direct response. 1.21e+11. What is the difference between the highest and the lowest Trade (in US$) of 1963?
Your response must be concise. 1.34e+11. 